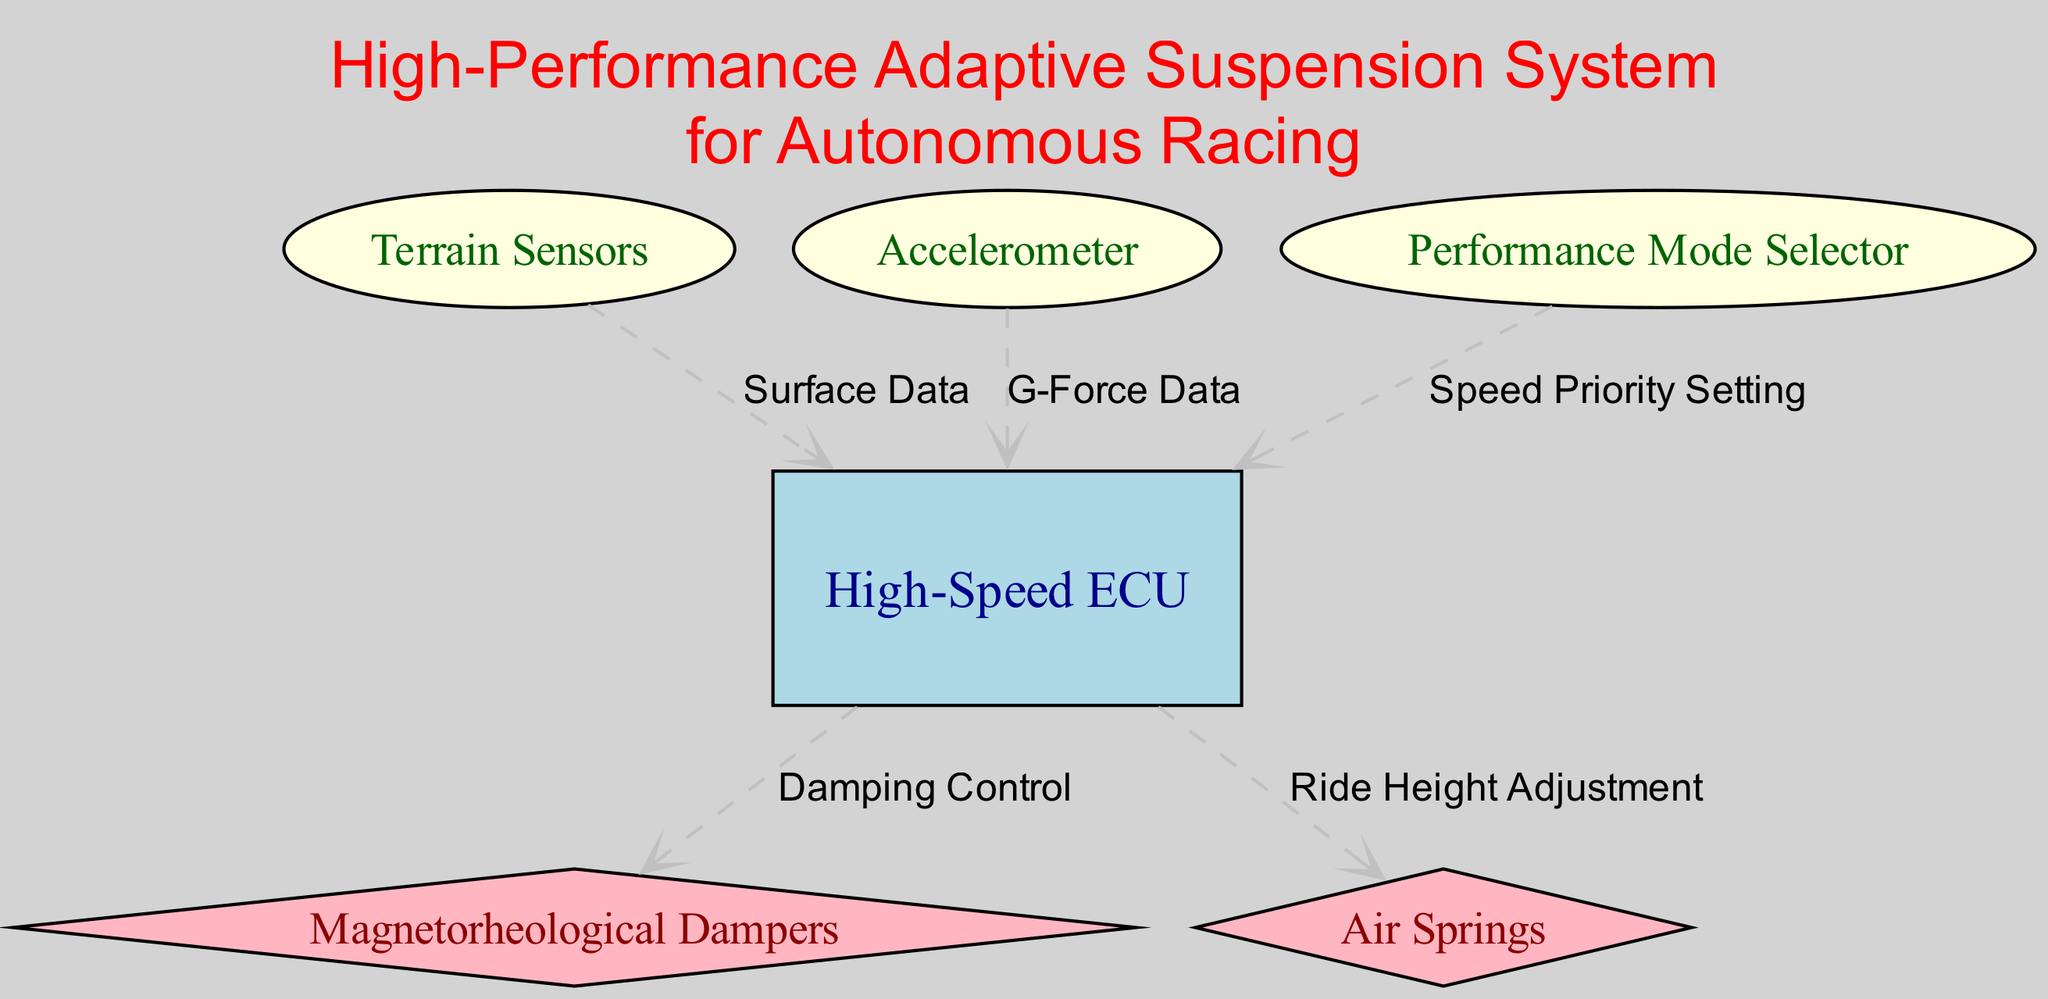What is the central node in the diagram? The central node is the "High-Speed ECU". It is positioned at the center of the diagram and connects to the majority of the other components in the adaptive suspension system.
Answer: High-Speed ECU How many nodes are present in the diagram? The diagram contains six nodes, including the High-Speed ECU, Terrain Sensors, Accelerometer, Magnetorheological Dampers, Air Springs, and Performance Mode Selector.
Answer: Six Which node receives "Surface Data"? The "Surface Data" flows from the "Terrain Sensors" to the "High-Speed ECU". This indicates that the ECU utilizes data from terrain sensors to adjust the vehicle's suspension system accordingly.
Answer: High-Speed ECU What is the relationship labeled as "Damping Control"? The relationship labeled as "Damping Control" connects the "High-Speed ECU" to the "Magnetorheological Dampers". This suggests that the ECU regulates the damping characteristics of the dampers based on the input it receives.
Answer: Damping Control Which sensor provides "G-Force Data"? The "G-Force Data" is provided by the "Accelerometer", which is tasked with measuring the acceleration forces acting on the vehicle. This data helps the ECU make adjustments for maintaining vehicle stability.
Answer: Accelerometer What does the "Performance Mode Selector" control? The "Performance Mode Selector" controls the "Speed Priority Setting" for the "High-Speed ECU", influencing how the autonomous vehicle prioritizes speed during its operation.
Answer: Speed Priority Setting Which component is responsible for "Ride Height Adjustment"? The "Ride Height Adjustment" is handled by the "Air Springs", which allows for modifications in the vehicle's suspension height based on driving conditions.
Answer: Air Springs How many edges are present in the diagram? The diagram has five edges, indicating the flow of information and control between the various nodes. This shows how data and control signals are transmitted throughout the adaptive suspension system.
Answer: Five Which elements communicate with the High-Speed ECU? The "High-Speed ECU" communicates with the "Magnetorheological Dampers", "Air Springs", "Terrain Sensors", "Accelerometer", and "Performance Mode Selector". Each of these elements plays a role in managing the vehicle's adaptive suspension system based on dynamic conditions.
Answer: Five elements 